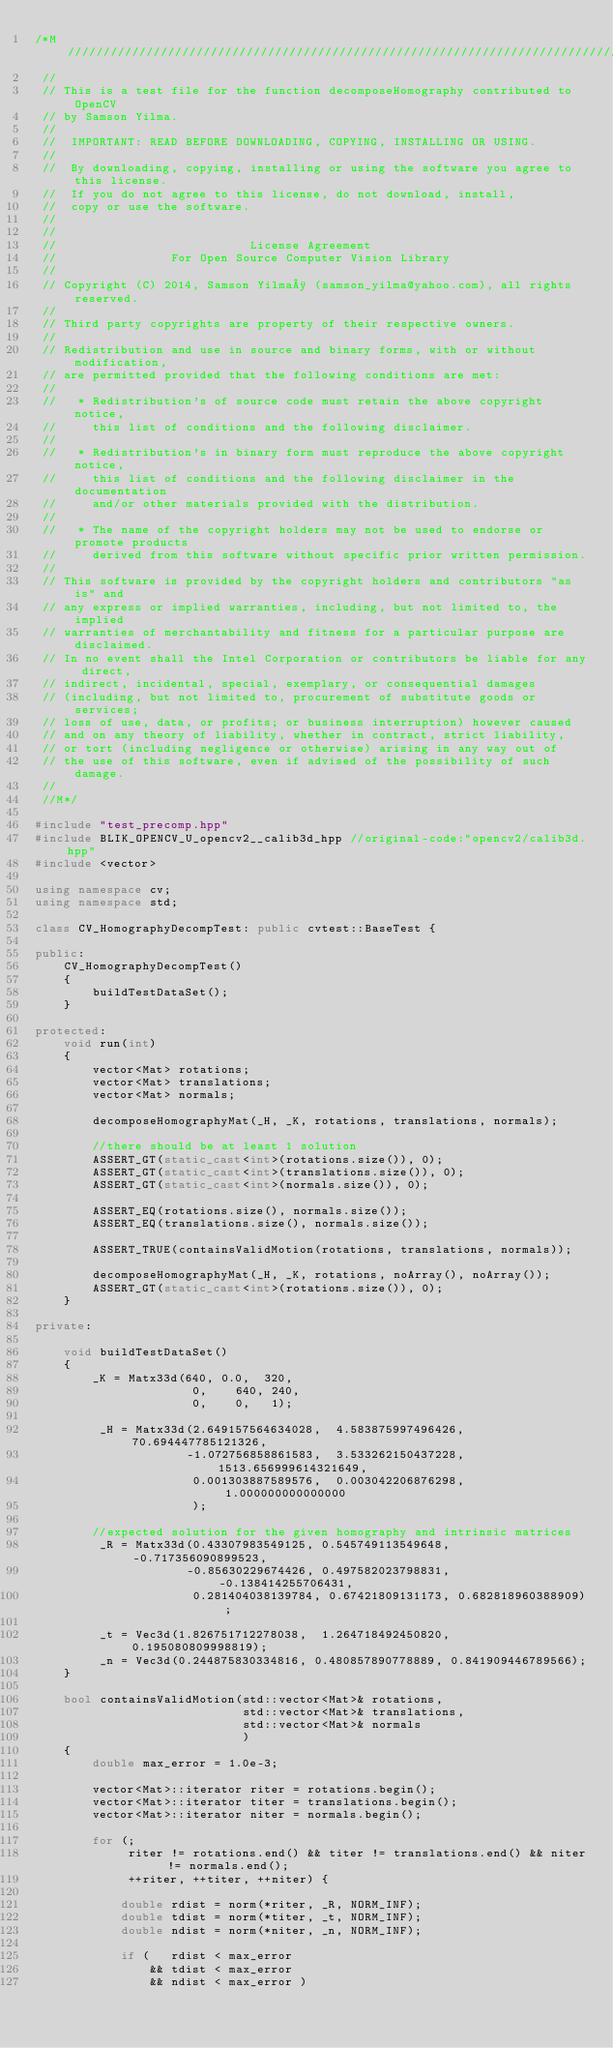<code> <loc_0><loc_0><loc_500><loc_500><_C++_>/*M///////////////////////////////////////////////////////////////////////////////////////
 //
 // This is a test file for the function decomposeHomography contributed to OpenCV
 // by Samson Yilma.
 //
 //  IMPORTANT: READ BEFORE DOWNLOADING, COPYING, INSTALLING OR USING.
 //
 //  By downloading, copying, installing or using the software you agree to this license.
 //  If you do not agree to this license, do not download, install,
 //  copy or use the software.
 //
 //
 //                           License Agreement
 //                For Open Source Computer Vision Library
 //
 // Copyright (C) 2014, Samson Yilma¸ (samson_yilma@yahoo.com), all rights reserved.
 //
 // Third party copyrights are property of their respective owners.
 //
 // Redistribution and use in source and binary forms, with or without modification,
 // are permitted provided that the following conditions are met:
 //
 //   * Redistribution's of source code must retain the above copyright notice,
 //     this list of conditions and the following disclaimer.
 //
 //   * Redistribution's in binary form must reproduce the above copyright notice,
 //     this list of conditions and the following disclaimer in the documentation
 //     and/or other materials provided with the distribution.
 //
 //   * The name of the copyright holders may not be used to endorse or promote products
 //     derived from this software without specific prior written permission.
 //
 // This software is provided by the copyright holders and contributors "as is" and
 // any express or implied warranties, including, but not limited to, the implied
 // warranties of merchantability and fitness for a particular purpose are disclaimed.
 // In no event shall the Intel Corporation or contributors be liable for any direct,
 // indirect, incidental, special, exemplary, or consequential damages
 // (including, but not limited to, procurement of substitute goods or services;
 // loss of use, data, or profits; or business interruption) however caused
 // and on any theory of liability, whether in contract, strict liability,
 // or tort (including negligence or otherwise) arising in any way out of
 // the use of this software, even if advised of the possibility of such damage.
 //
 //M*/

#include "test_precomp.hpp"
#include BLIK_OPENCV_U_opencv2__calib3d_hpp //original-code:"opencv2/calib3d.hpp"
#include <vector>

using namespace cv;
using namespace std;

class CV_HomographyDecompTest: public cvtest::BaseTest {

public:
    CV_HomographyDecompTest()
    {
        buildTestDataSet();
    }

protected:
    void run(int)
    {
        vector<Mat> rotations;
        vector<Mat> translations;
        vector<Mat> normals;

        decomposeHomographyMat(_H, _K, rotations, translations, normals);

        //there should be at least 1 solution
        ASSERT_GT(static_cast<int>(rotations.size()), 0);
        ASSERT_GT(static_cast<int>(translations.size()), 0);
        ASSERT_GT(static_cast<int>(normals.size()), 0);

        ASSERT_EQ(rotations.size(), normals.size());
        ASSERT_EQ(translations.size(), normals.size());

        ASSERT_TRUE(containsValidMotion(rotations, translations, normals));

        decomposeHomographyMat(_H, _K, rotations, noArray(), noArray());
        ASSERT_GT(static_cast<int>(rotations.size()), 0);
    }

private:

    void buildTestDataSet()
    {
        _K = Matx33d(640, 0.0,  320,
                      0,    640, 240,
                      0,    0,   1);

         _H = Matx33d(2.649157564634028,  4.583875997496426,  70.694447785121326,
                     -1.072756858861583,  3.533262150437228,  1513.656999614321649,
                      0.001303887589576,  0.003042206876298,  1.000000000000000
                      );

        //expected solution for the given homography and intrinsic matrices
         _R = Matx33d(0.43307983549125, 0.545749113549648, -0.717356090899523,
                     -0.85630229674426, 0.497582023798831, -0.138414255706431,
                      0.281404038139784, 0.67421809131173, 0.682818960388909);

         _t = Vec3d(1.826751712278038,  1.264718492450820,  0.195080809998819);
         _n = Vec3d(0.244875830334816, 0.480857890778889, 0.841909446789566);
    }

    bool containsValidMotion(std::vector<Mat>& rotations,
                             std::vector<Mat>& translations,
                             std::vector<Mat>& normals
                             )
    {
        double max_error = 1.0e-3;

        vector<Mat>::iterator riter = rotations.begin();
        vector<Mat>::iterator titer = translations.begin();
        vector<Mat>::iterator niter = normals.begin();

        for (;
             riter != rotations.end() && titer != translations.end() && niter != normals.end();
             ++riter, ++titer, ++niter) {

            double rdist = norm(*riter, _R, NORM_INF);
            double tdist = norm(*titer, _t, NORM_INF);
            double ndist = norm(*niter, _n, NORM_INF);

            if (   rdist < max_error
                && tdist < max_error
                && ndist < max_error )</code> 